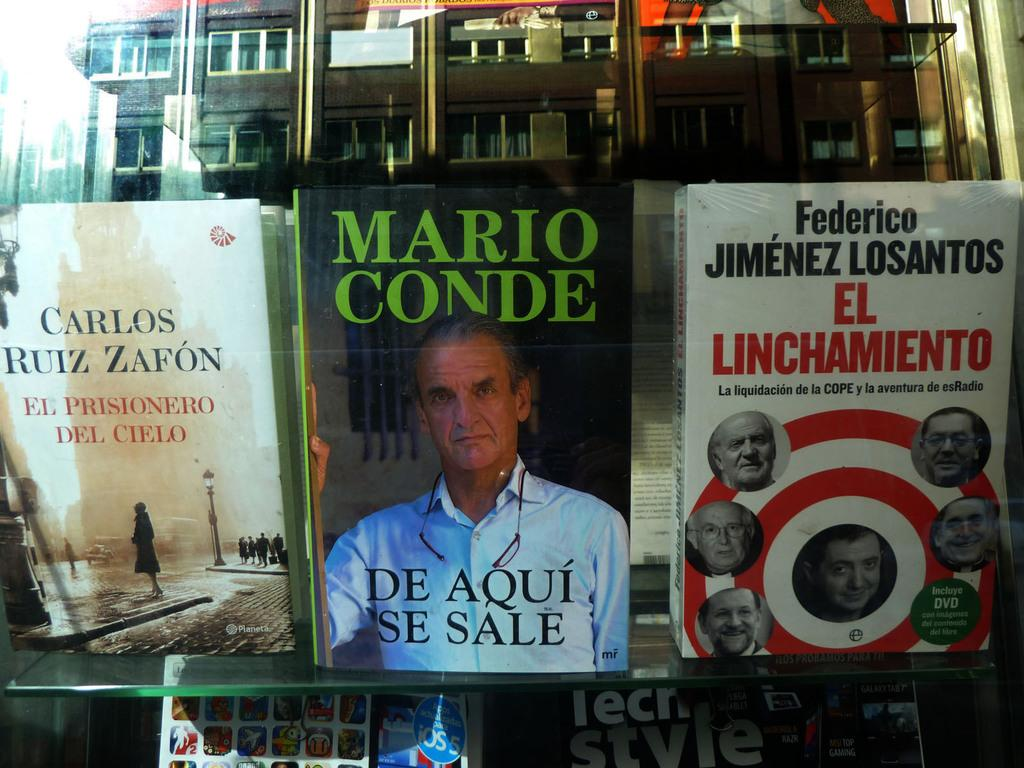<image>
Give a short and clear explanation of the subsequent image. Three spanish books on a glass shelf with the middle one called De Aqui Se Sale by Mario Conde 